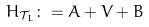Convert formula to latex. <formula><loc_0><loc_0><loc_500><loc_500>H _ { \mathcal { T } _ { L } } \colon = A + V + B \,</formula> 